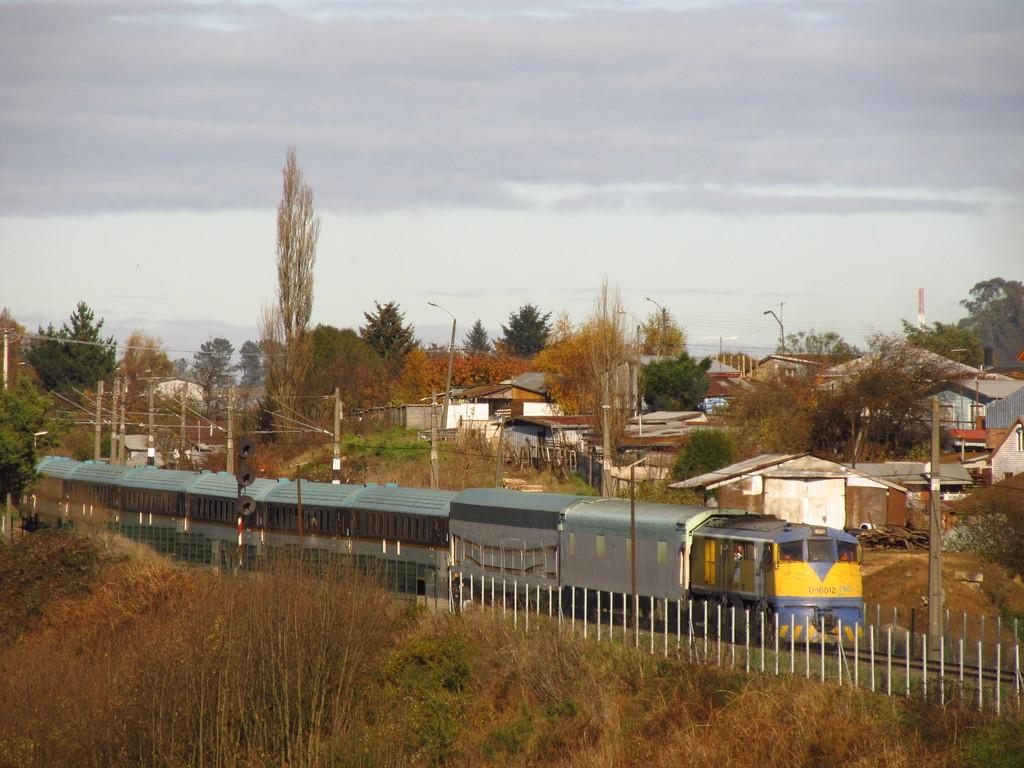What type of vegetation is at the bottom of the image? There are trees at the bottom of the image. What is moving in the middle of the image? A train is moving on the track in the middle of the image. What type of structures are present in the image? There are iron sheds in the image. What type of buildings can be seen in the image? There are houses in the image. What is visible at the top of the image? The sky is visible at the top of the image. How many quarters are visible on the train in the image? There are no quarters visible on the train in the image. What type of paper is being used to cover the windows of the houses in the image? There is no paper covering the windows of the houses in the image. 